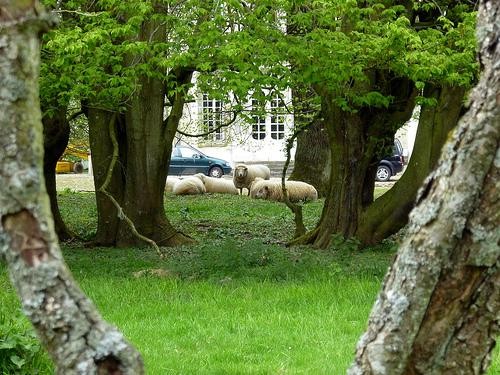Question: how many windows are in the background?
Choices:
A. 2.
B. 4.
C. 1.
D. 3.
Answer with the letter. Answer: D Question: what animals are shown?
Choices:
A. Goats.
B. Sheep.
C. Cows.
D. Horses.
Answer with the letter. Answer: B Question: what are the sheep lying on?
Choices:
A. Grass.
B. Hay.
C. Rocks.
D. Snow.
Answer with the letter. Answer: A 